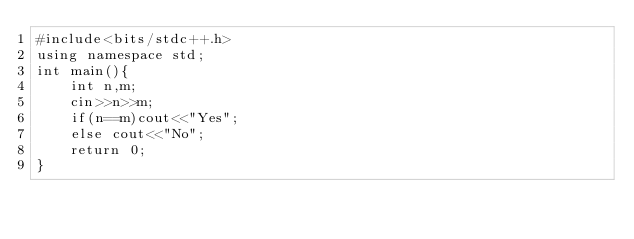<code> <loc_0><loc_0><loc_500><loc_500><_C++_>#include<bits/stdc++.h>
using namespace std;
int main(){
	int n,m;
	cin>>n>>m;
	if(n==m)cout<<"Yes";
	else cout<<"No"; 
	return 0;
}
</code> 